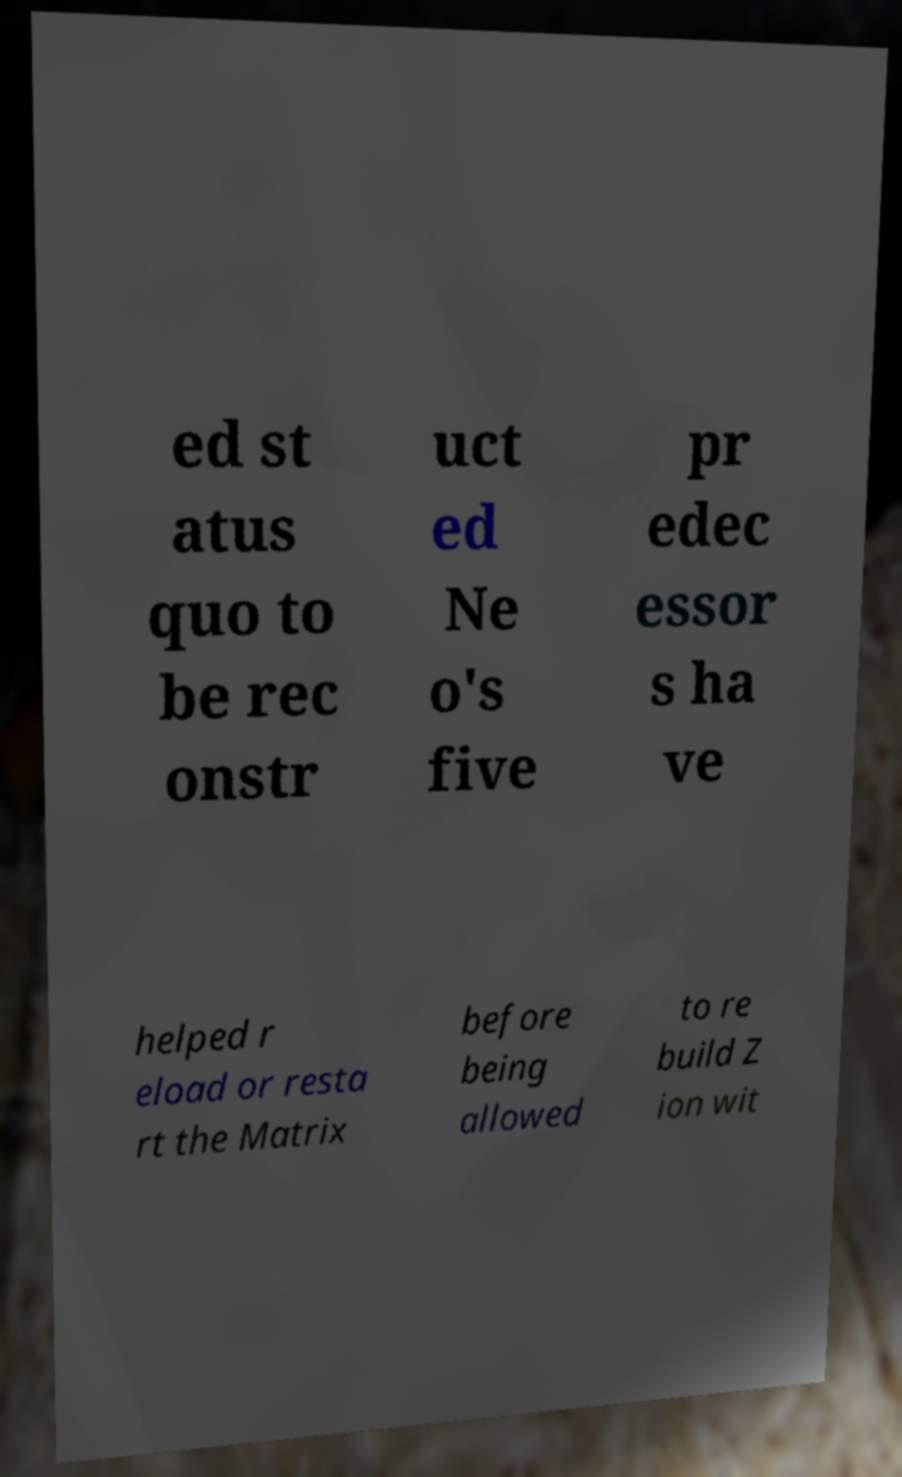Please identify and transcribe the text found in this image. ed st atus quo to be rec onstr uct ed Ne o's five pr edec essor s ha ve helped r eload or resta rt the Matrix before being allowed to re build Z ion wit 